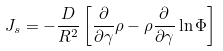Convert formula to latex. <formula><loc_0><loc_0><loc_500><loc_500>J _ { s } = - \frac { D } { R ^ { 2 } } \left [ \frac { \partial } { \partial \gamma } \rho - \rho \frac { \partial } { \partial \gamma } \ln \Phi \right ]</formula> 